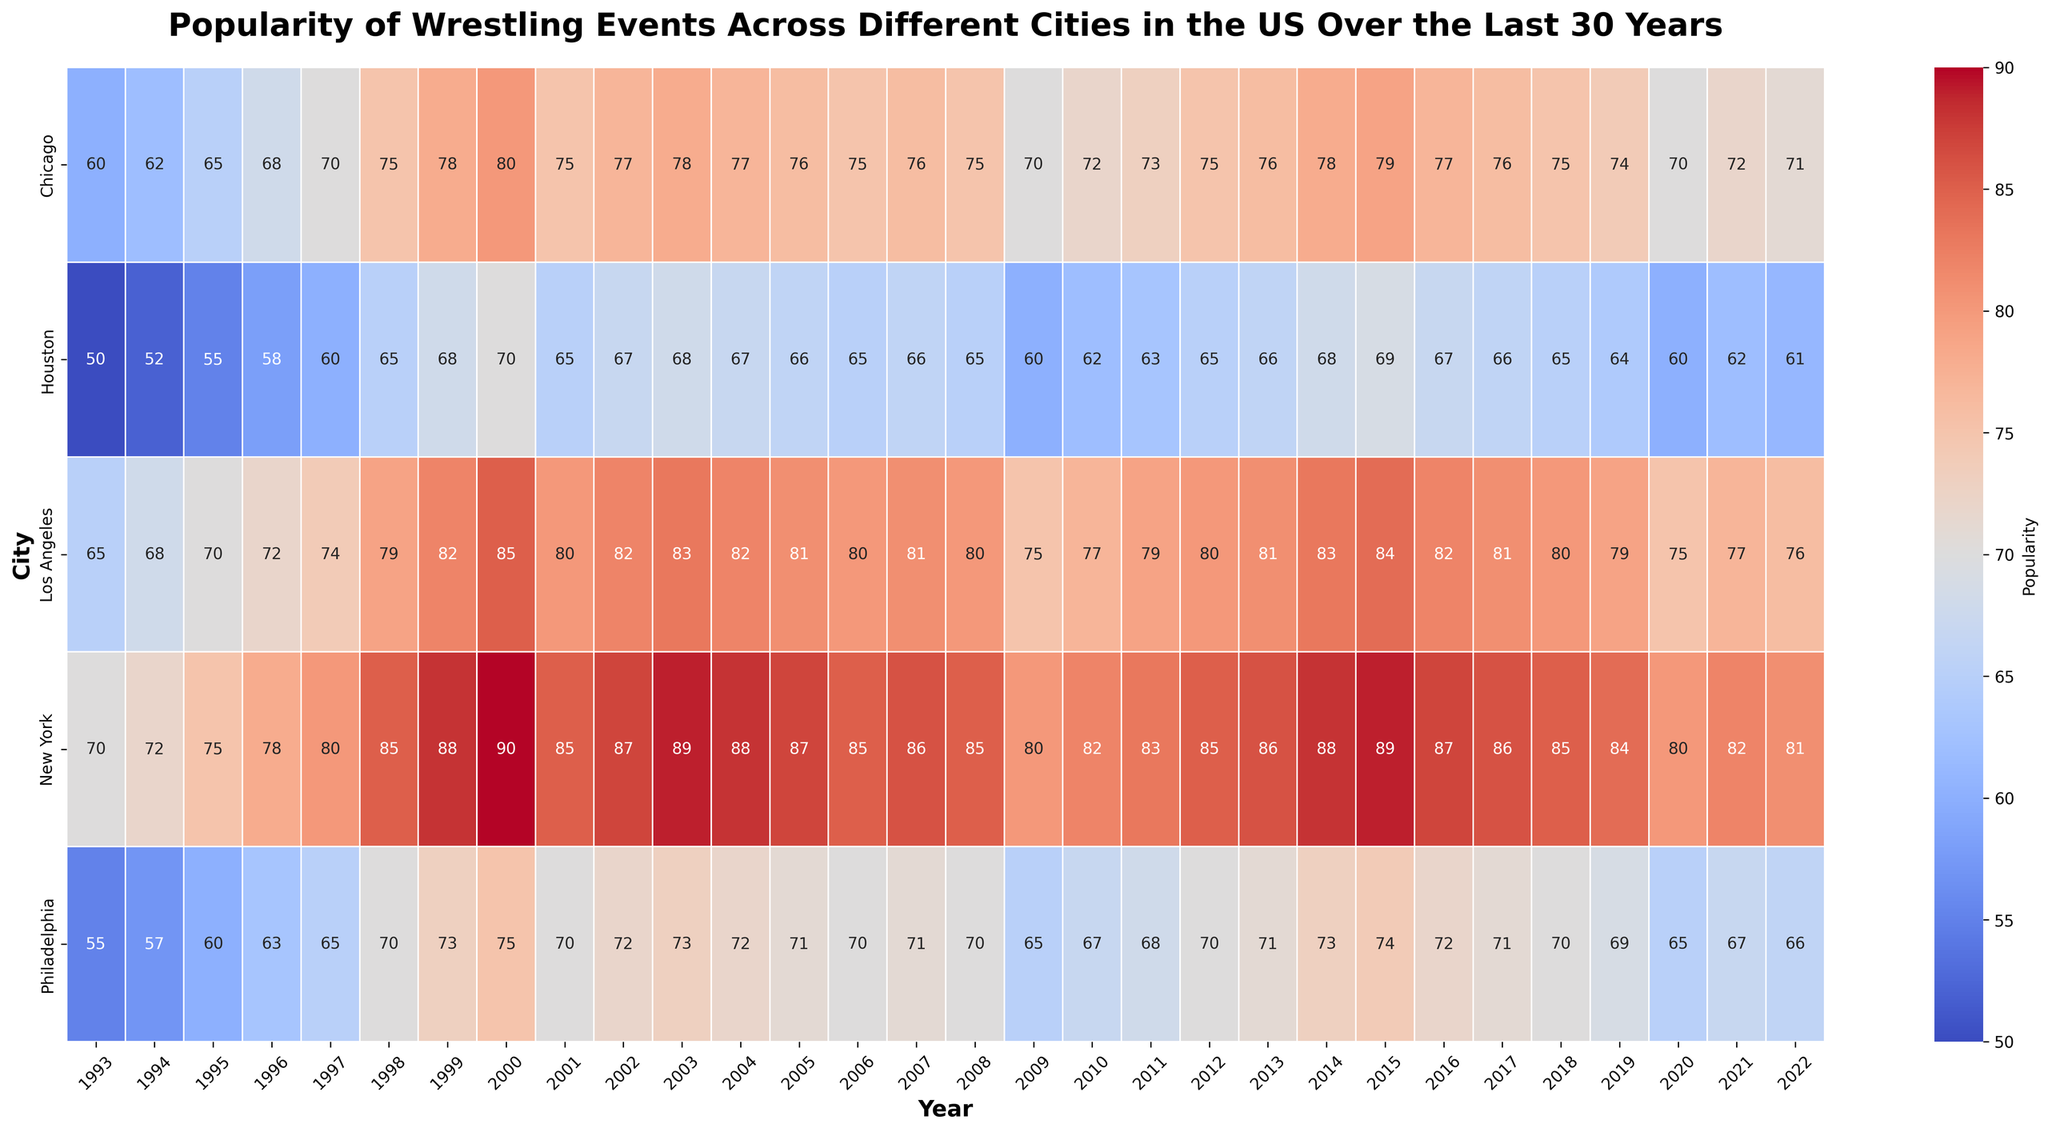Which city had the highest popularity for wrestling events in 1998? Observe the heatmap, look for the year 1998, and identify the city with the highest popularity. The city with the deepest red color for 1998 indicates the highest popularity.
Answer: New York Which city showed the most significant drop in popularity from 2000 to 2001? Compare the values for each city in 2000 and 2001. Compute the difference by subtracting the 2001 value from the 2000 value for each city to determine the most significant drop.
Answer: New York Which year did Los Angeles experience the highest popularity for wrestling events? Find the row corresponding to Los Angeles and identify the year with the highest popularity value, represented by the deepest red color in that row.
Answer: 2000 Which city had the lowest popularity for wrestling events in 2005? Check the heatmap for the year 2005 and identify the city with the lowest popularity, indicated by the lightest color for 2005.
Answer: Houston What's the average popularity of wrestling events in New York over the entire period? Sum the popularity values for New York over all years and divide by the total number of years. Sum = 2470; Number of years = 30; Average = 2470/30 ≈ 82.33
Answer: 82.33 Which city had a consistent increase in popularity over the first five years? Examine the heatmap for the first five years (1993-1997) and identify the city with increasing popularity values each year during that period.
Answer: All Cities Compare the popularity trend of wrestling events in Chicago and Los Angeles from 2007 to 2009. Look at the popularity values for Chicago and Los Angeles from 2007 to 2009. For Chicago: 76 to 75 to 70 (decreasing trend). For Los Angeles: 81 to 80 to 75 (decreasing trend). Both show a decreasing trend, but you can state the difference in the rate of decrease, with Chicago dropping by 6 and Los Angeles by 6 as well.
Answer: Both cities experienced a decrease Which city experienced the smallest change in popularity between 2010 and 2015? Compare the popularity values for each city from 2010 to 2015 and compute the absolute difference for each city. Philadelphia: 74 - 67 = 7; Houston: 69 - 62 = 7; Los Angeles: 84 - 77 = 7; New York: 89 - 82 = 7; Chicago: 79 - 72 = 7.
Answer: All Cities What is the overall trend in popularity for Houston from 1993 to 2022? Observe the heatmap row for Houston to determine the general trend from light to dark shades. Initially increased, then fluctuated
Answer: Increased, then fluctuated Which city had the second highest popularity in 2014? Examine the popularity values for all cities in 2014 and determine the second highest value. New York had highest (88), Los Angeles the second highest (83).
Answer: Los Angeles 